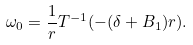<formula> <loc_0><loc_0><loc_500><loc_500>\omega _ { 0 } = \frac { 1 } { r } T ^ { - 1 } ( - ( \delta + B _ { 1 } ) r ) .</formula> 